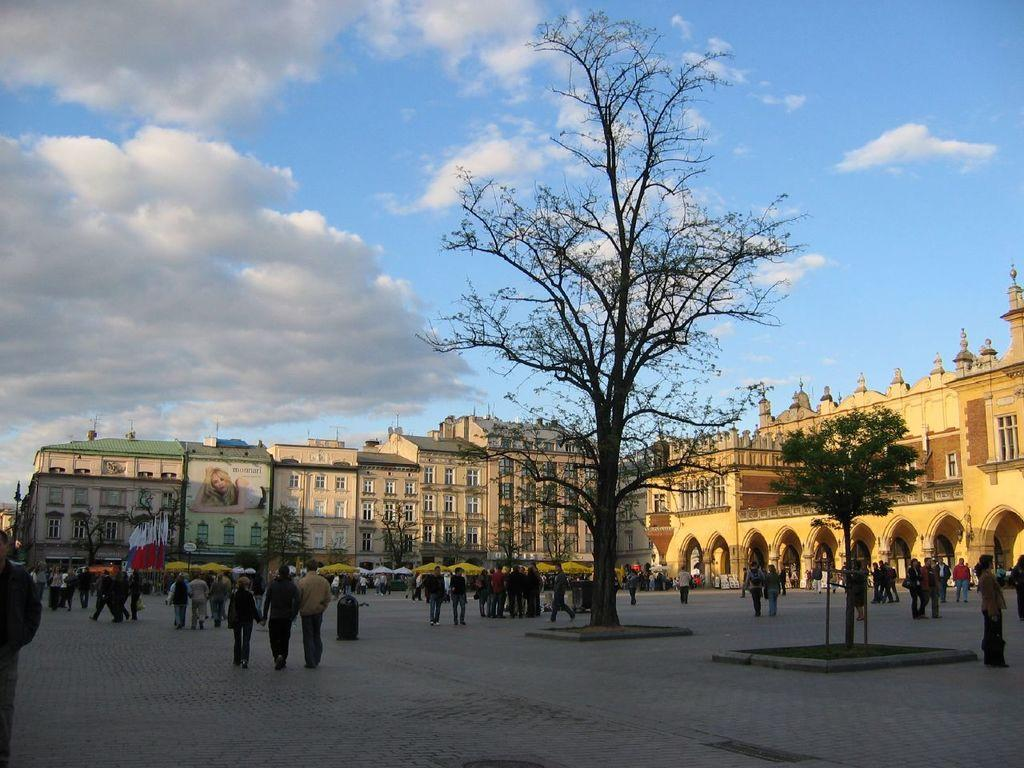What are the people in the image wearing? The persons in the image are wearing clothes. What can be seen in the middle of the image? There are buildings and trees in the middle of the image. What is visible at the top of the image? The sky is visible at the top of the image. What type of clam is being sold at the shop in the image? There is no shop or clam present in the image. What song is being played in the background of the image? There is no music or song playing in the image. 